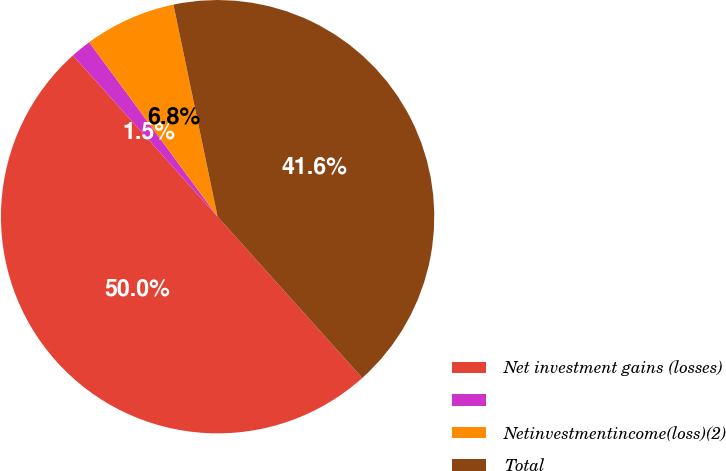Convert chart. <chart><loc_0><loc_0><loc_500><loc_500><pie_chart><fcel>Net investment gains (losses)<fcel>Unnamed: 1<fcel>Netinvestmentincome(loss)(2)<fcel>Total<nl><fcel>50.0%<fcel>1.54%<fcel>6.83%<fcel>41.63%<nl></chart> 